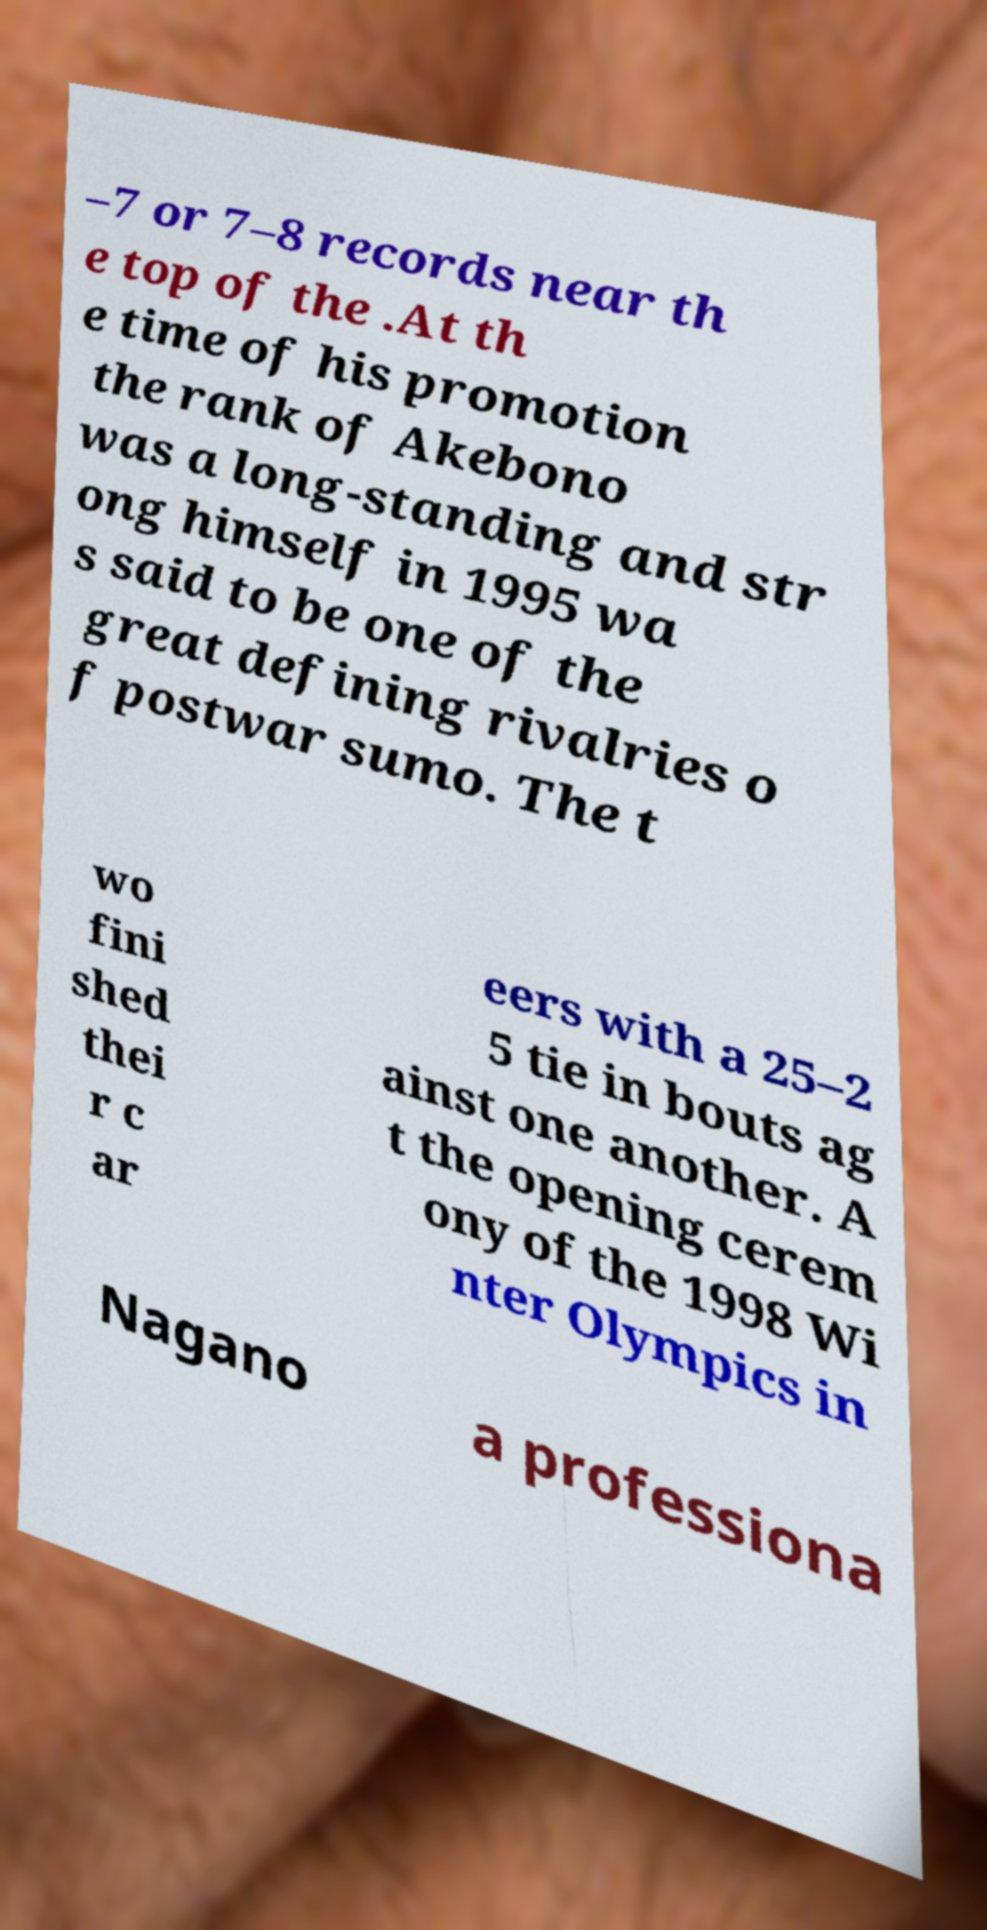For documentation purposes, I need the text within this image transcribed. Could you provide that? –7 or 7–8 records near th e top of the .At th e time of his promotion the rank of Akebono was a long-standing and str ong himself in 1995 wa s said to be one of the great defining rivalries o f postwar sumo. The t wo fini shed thei r c ar eers with a 25–2 5 tie in bouts ag ainst one another. A t the opening cerem ony of the 1998 Wi nter Olympics in Nagano a professiona 